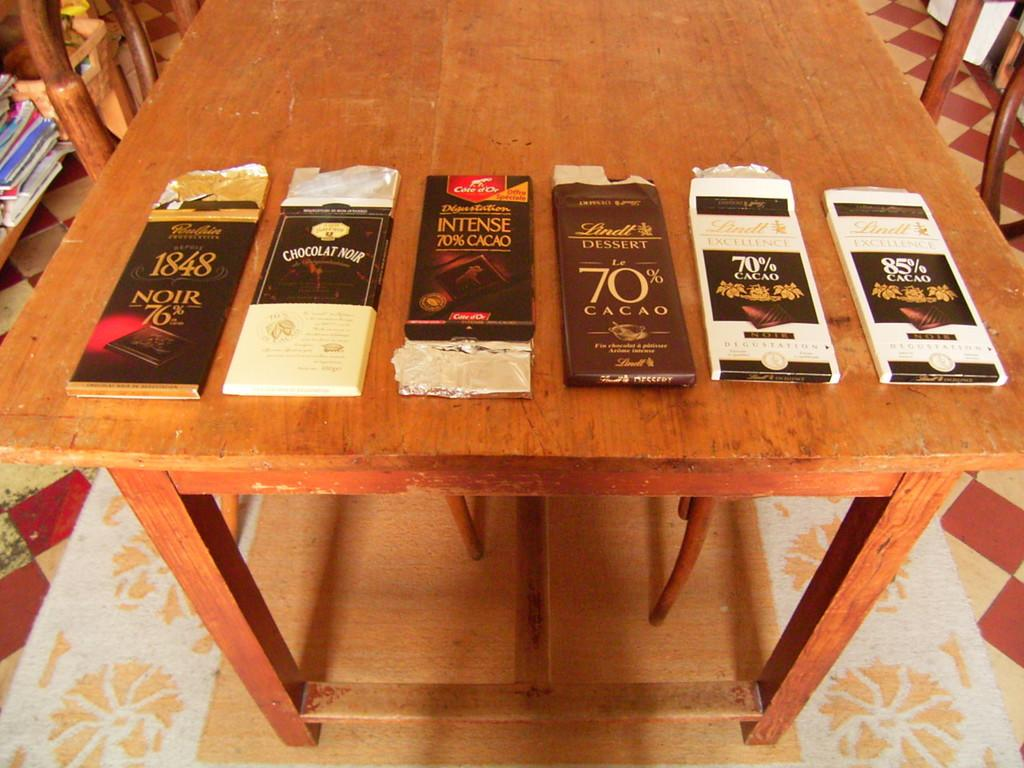<image>
Provide a brief description of the given image. several bars of chocolate on a table include 1848 Noir 